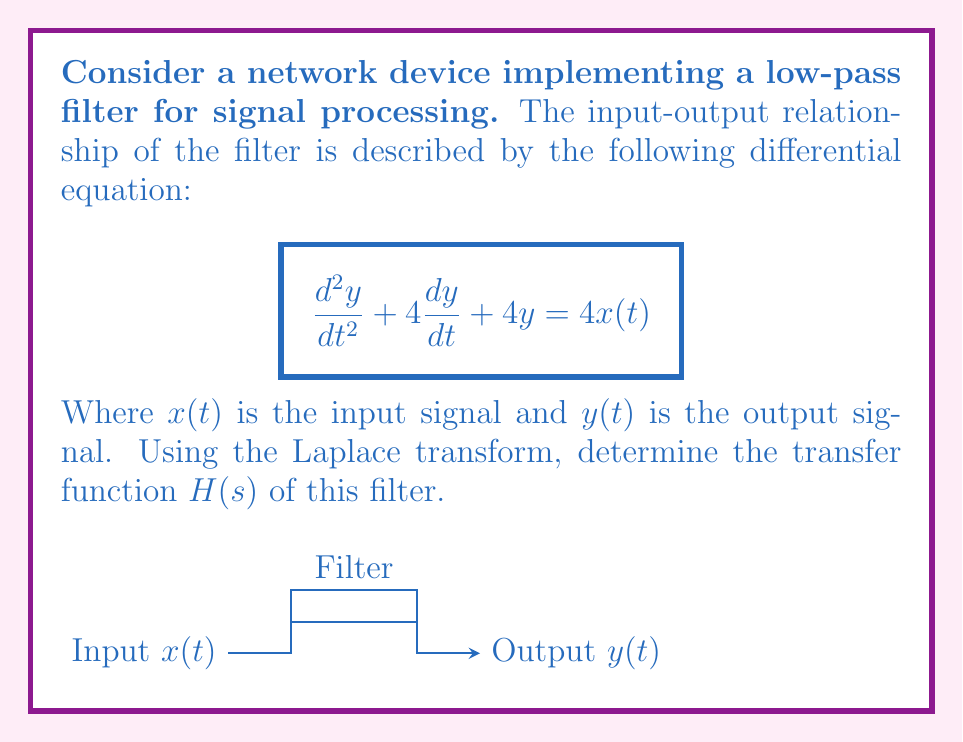Could you help me with this problem? To solve this problem, we'll follow these steps:

1) First, let's take the Laplace transform of both sides of the differential equation:

   $\mathcal{L}\{\frac{d^2y}{dt^2} + 4\frac{dy}{dt} + 4y\} = \mathcal{L}\{4x(t)\}$

2) Using the properties of Laplace transforms:

   $(s^2Y(s) - sy(0) - y'(0)) + 4(sY(s) - y(0)) + 4Y(s) = 4X(s)$

3) Assuming zero initial conditions (i.e., $y(0) = 0$ and $y'(0) = 0$):

   $s^2Y(s) + 4sY(s) + 4Y(s) = 4X(s)$

4) Factor out $Y(s)$:

   $Y(s)(s^2 + 4s + 4) = 4X(s)$

5) Solve for $Y(s)$:

   $Y(s) = \frac{4X(s)}{s^2 + 4s + 4}$

6) The transfer function $H(s)$ is defined as the ratio of output to input in the s-domain:

   $H(s) = \frac{Y(s)}{X(s)} = \frac{4}{s^2 + 4s + 4}$

7) We can factor the denominator:

   $H(s) = \frac{4}{(s+2)^2}$

This is the transfer function of the low-pass filter implemented in the network device.
Answer: $H(s) = \frac{4}{(s+2)^2}$ 